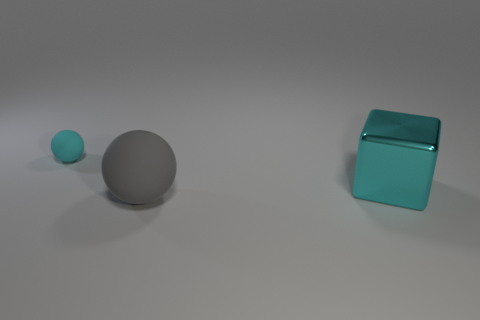The ball that is made of the same material as the small object is what size? The ball made of the same material as the small teal object appears to be the medium-sized grey ball. 